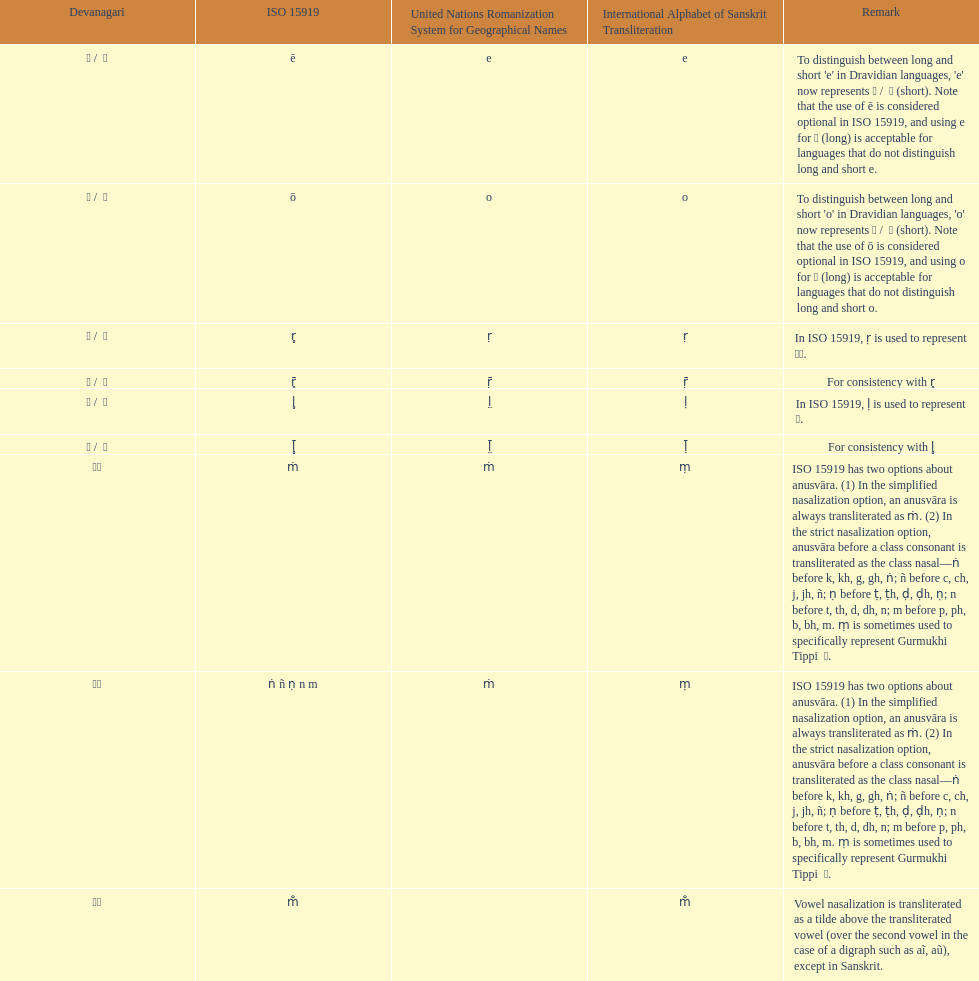How many total options are there about anusvara? 2. 